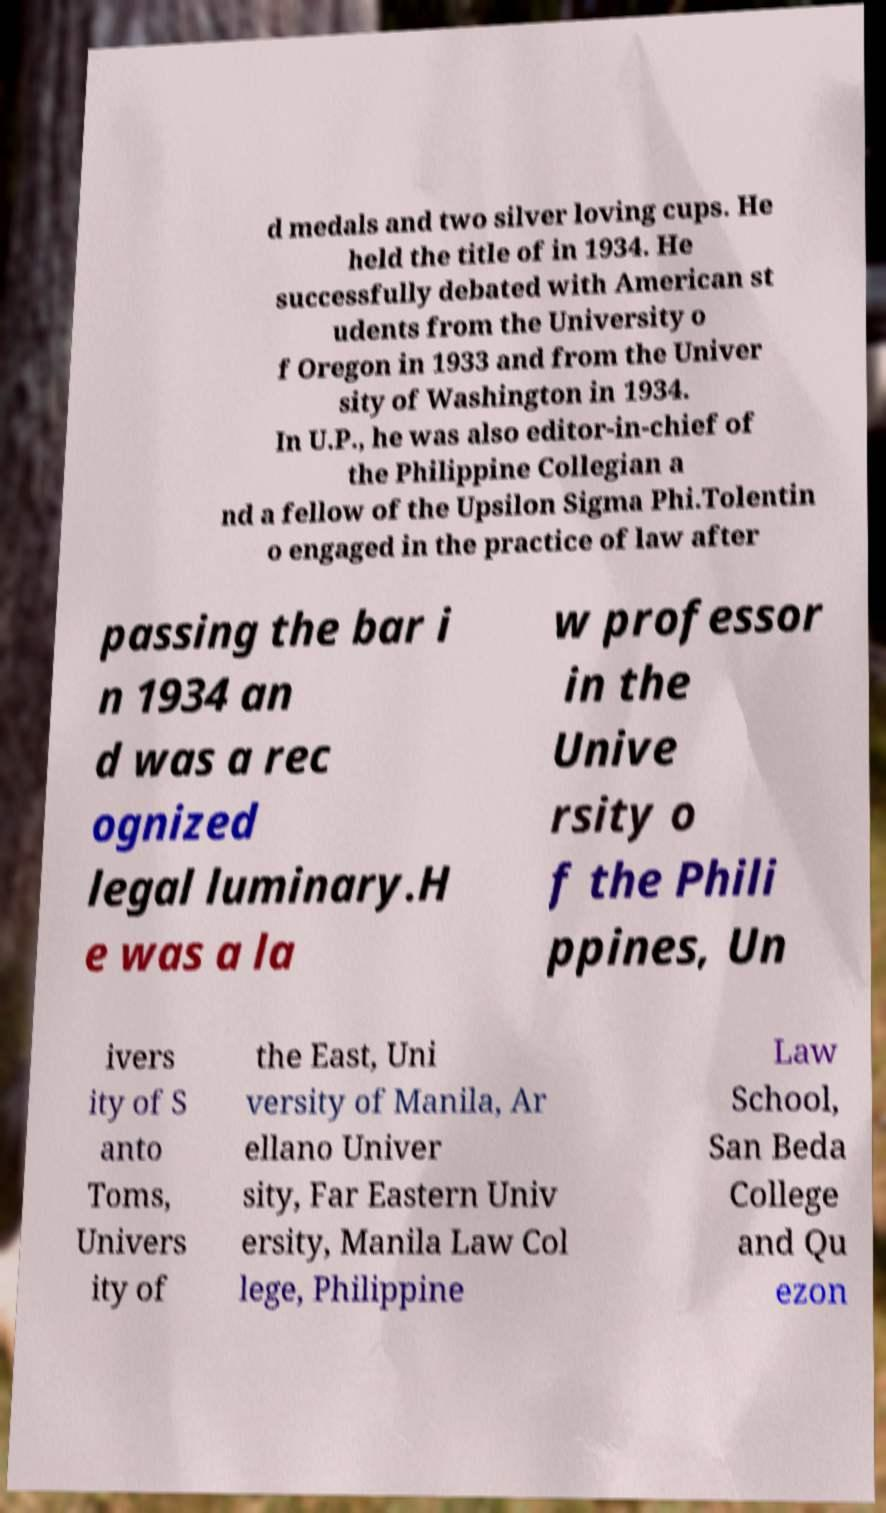Please read and relay the text visible in this image. What does it say? d medals and two silver loving cups. He held the title of in 1934. He successfully debated with American st udents from the University o f Oregon in 1933 and from the Univer sity of Washington in 1934. In U.P., he was also editor-in-chief of the Philippine Collegian a nd a fellow of the Upsilon Sigma Phi.Tolentin o engaged in the practice of law after passing the bar i n 1934 an d was a rec ognized legal luminary.H e was a la w professor in the Unive rsity o f the Phili ppines, Un ivers ity of S anto Toms, Univers ity of the East, Uni versity of Manila, Ar ellano Univer sity, Far Eastern Univ ersity, Manila Law Col lege, Philippine Law School, San Beda College and Qu ezon 